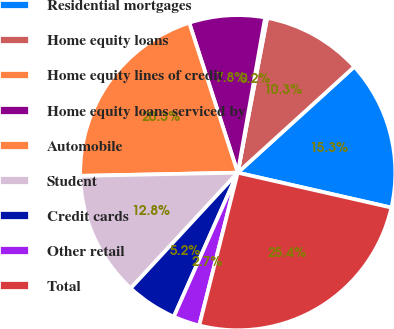<chart> <loc_0><loc_0><loc_500><loc_500><pie_chart><fcel>Residential mortgages<fcel>Home equity loans<fcel>Home equity lines of credit<fcel>Home equity loans serviced by<fcel>Automobile<fcel>Student<fcel>Credit cards<fcel>Other retail<fcel>Total<nl><fcel>15.3%<fcel>10.27%<fcel>0.21%<fcel>7.76%<fcel>20.34%<fcel>12.79%<fcel>5.24%<fcel>2.72%<fcel>25.37%<nl></chart> 